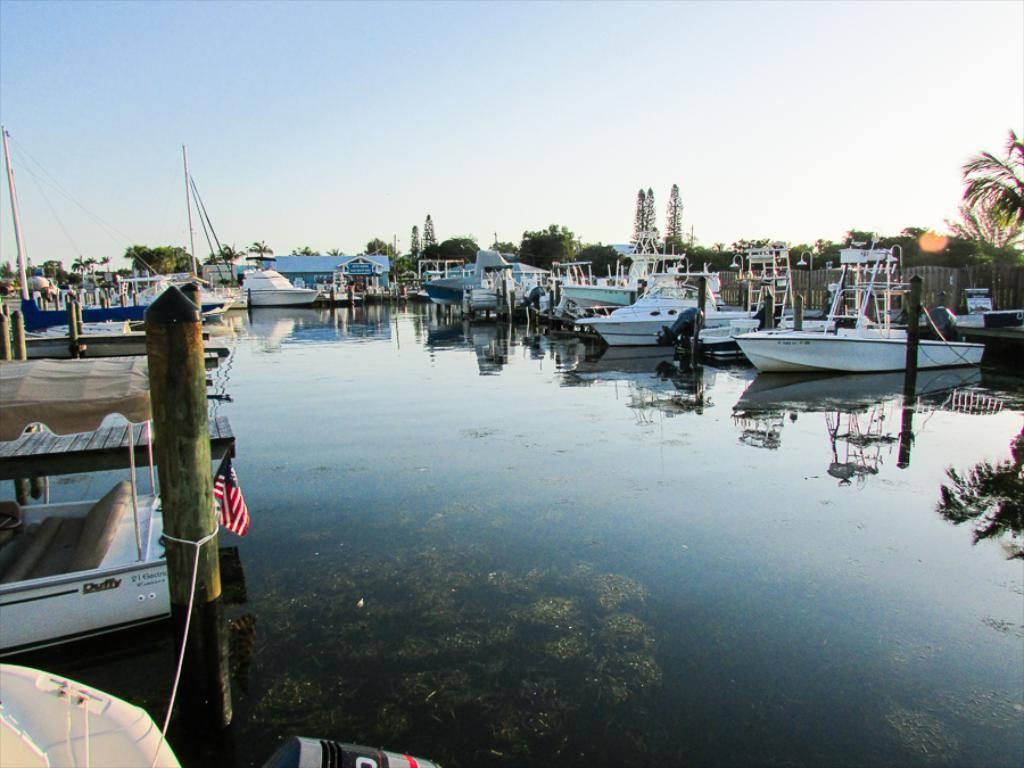What is the primary element visible in the image? There is water in the image. What type of vehicles can be seen in the water? There are boats in the image, and they are white in color. What object made of wood is present in the image? There is a wooden pole in the image. What type of vegetation is visible in the image? There are trees in the image. What can be seen in the background of the image? The sky is visible in the background of the image. What type of statement can be seen written on the boats in the image? There are no statements visible on the boats in the image; they are simply white in color. How much rice is being transported by the boats in the image? There is no rice visible in the image, and the boats are not shown transporting any cargo. 